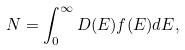<formula> <loc_0><loc_0><loc_500><loc_500>N = \int _ { 0 } ^ { \infty } D ( E ) f ( E ) d E ,</formula> 